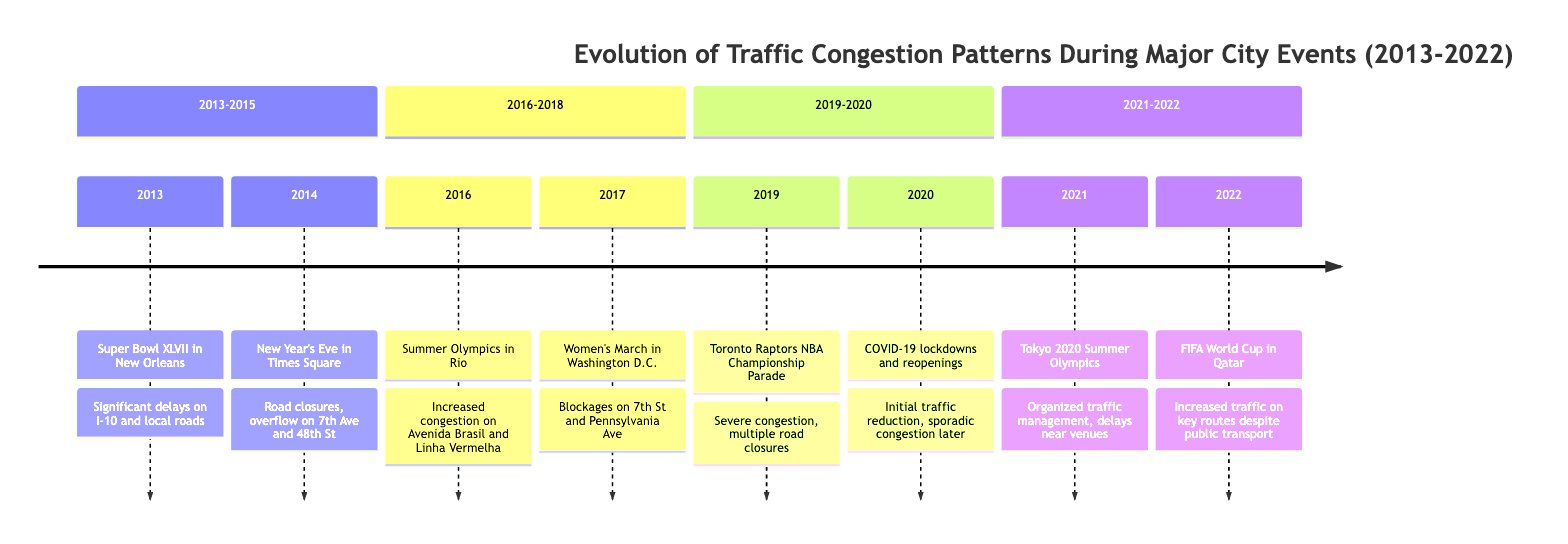What major event caused significant delays on I-10 in 2013? The diagram indicates that Super Bowl XLVII in New Orleans led to significant delays on I-10 and local roads. This information is located in the timeline element for the year 2013.
Answer: Super Bowl XLVII What was the traffic congestion pattern during the New Year's Eve in 2014? For 2014, the timeline shows that New Year's Eve in Times Square resulted in road closures leading to overflow on 7th Avenue and 48th Street. This is directly stated in the corresponding element.
Answer: Road closures, overflow on 7th Avenue and 48th Street Which event in 2019 caused severe congestion along University Avenue? According to the 2019 entry in the timeline, the Toronto Raptors NBA Championship Parade caused severe congestion along University Avenue and Queen Street West. This confirms the specific locations impacted.
Answer: Toronto Raptors NBA Championship Parade What type of traffic management was employed during the Tokyo 2020 Summer Olympics in 2021? The timeline detail for 2021 indicates that Tokyo 2020 Summer Olympics featured highly organized traffic management, although there were still delays near Olympic venues. This implies a structured approach to managing traffic.
Answer: Highly organized traffic management During which event did massive pedestrian influx cause blockages in Washington D.C.? The timeline specifies that the Women's March in Washington D.C. in 2017 led to massive pedestrian influx causing blockages on 7th Street and Pennsylvania Avenue. This identifies the event and its consequences on traffic flow.
Answer: Women's March What was the general trend in traffic during the COVID-19 lockdowns of 2020? The timeline for 2020 summarizes that there was an initial reduction in traffic due to lockdowns, which was later followed by sporadic congestion during phased reopenings. This shows the dual nature of traffic changes during that year.
Answer: Initial reduction, sporadic congestion What was the traffic situation around FIFA World Cup in 2022 despite expanded public transport? According to the entry for 2022, the FIFA World Cup in Qatar led to increased traffic on key routes such as Corniche Street and Lusail Expressway, even with expanded public transport options available. This indicates a paradox of increased traffic despite improvements in public transit.
Answer: Increased traffic on key routes How many major events are mentioned in the timeline from 2013 to 2022? By counting the distinct events presented in the timeline, we see there are eight major events listed from 2013 to 2022. Therefore, the answer reflects the total number of entries in the provided timeline data.
Answer: Eight events Which year experienced a significant reduction in traffic due to external circumstances? The timeline specifies that 2020 experienced an initial reduction in traffic due to COVID-19 lockdowns. This directly highlights the impact of the pandemic on traffic patterns.
Answer: 2020 